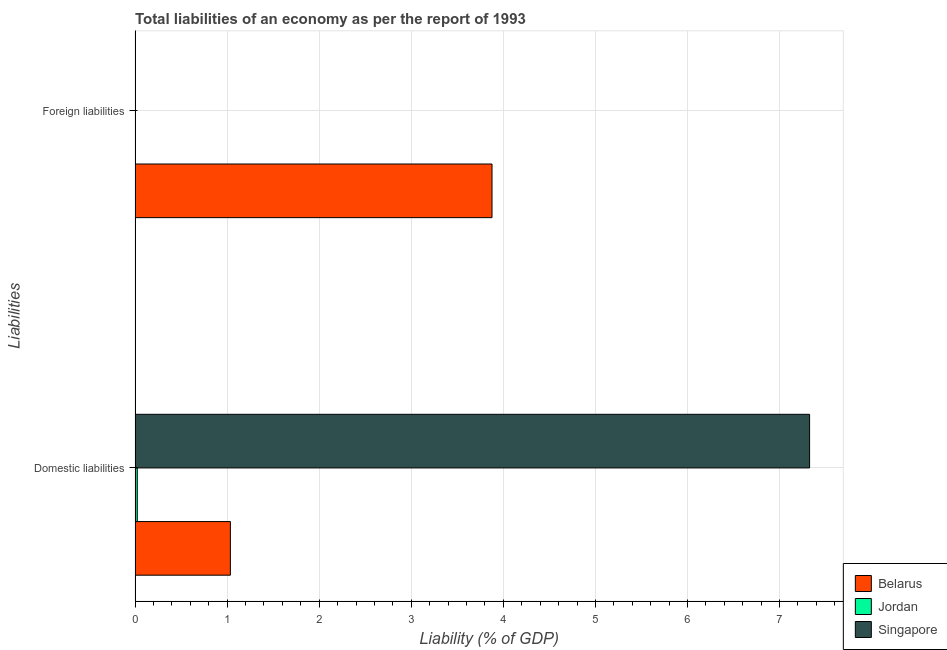How many different coloured bars are there?
Offer a terse response. 3. How many bars are there on the 1st tick from the bottom?
Your answer should be very brief. 3. What is the label of the 2nd group of bars from the top?
Your answer should be very brief. Domestic liabilities. What is the incurrence of foreign liabilities in Jordan?
Offer a terse response. 0. Across all countries, what is the maximum incurrence of domestic liabilities?
Provide a succinct answer. 7.33. Across all countries, what is the minimum incurrence of domestic liabilities?
Your answer should be compact. 0.02. In which country was the incurrence of foreign liabilities maximum?
Your answer should be very brief. Belarus. What is the total incurrence of domestic liabilities in the graph?
Your answer should be very brief. 8.39. What is the difference between the incurrence of domestic liabilities in Singapore and that in Jordan?
Your answer should be compact. 7.3. What is the difference between the incurrence of domestic liabilities in Belarus and the incurrence of foreign liabilities in Jordan?
Give a very brief answer. 1.04. What is the average incurrence of foreign liabilities per country?
Provide a short and direct response. 1.29. What is the difference between the incurrence of foreign liabilities and incurrence of domestic liabilities in Belarus?
Provide a short and direct response. 2.84. What is the ratio of the incurrence of domestic liabilities in Belarus to that in Jordan?
Provide a succinct answer. 43.24. How many countries are there in the graph?
Offer a terse response. 3. Are the values on the major ticks of X-axis written in scientific E-notation?
Your response must be concise. No. Does the graph contain any zero values?
Keep it short and to the point. Yes. Does the graph contain grids?
Keep it short and to the point. Yes. What is the title of the graph?
Offer a very short reply. Total liabilities of an economy as per the report of 1993. What is the label or title of the X-axis?
Keep it short and to the point. Liability (% of GDP). What is the label or title of the Y-axis?
Make the answer very short. Liabilities. What is the Liability (% of GDP) in Belarus in Domestic liabilities?
Keep it short and to the point. 1.04. What is the Liability (% of GDP) of Jordan in Domestic liabilities?
Offer a very short reply. 0.02. What is the Liability (% of GDP) in Singapore in Domestic liabilities?
Make the answer very short. 7.33. What is the Liability (% of GDP) in Belarus in Foreign liabilities?
Your answer should be compact. 3.88. Across all Liabilities, what is the maximum Liability (% of GDP) of Belarus?
Give a very brief answer. 3.88. Across all Liabilities, what is the maximum Liability (% of GDP) of Jordan?
Ensure brevity in your answer.  0.02. Across all Liabilities, what is the maximum Liability (% of GDP) of Singapore?
Offer a very short reply. 7.33. Across all Liabilities, what is the minimum Liability (% of GDP) of Belarus?
Give a very brief answer. 1.04. Across all Liabilities, what is the minimum Liability (% of GDP) of Singapore?
Provide a succinct answer. 0. What is the total Liability (% of GDP) of Belarus in the graph?
Offer a very short reply. 4.91. What is the total Liability (% of GDP) in Jordan in the graph?
Ensure brevity in your answer.  0.02. What is the total Liability (% of GDP) in Singapore in the graph?
Make the answer very short. 7.33. What is the difference between the Liability (% of GDP) in Belarus in Domestic liabilities and that in Foreign liabilities?
Provide a succinct answer. -2.84. What is the average Liability (% of GDP) in Belarus per Liabilities?
Your response must be concise. 2.46. What is the average Liability (% of GDP) of Jordan per Liabilities?
Offer a terse response. 0.01. What is the average Liability (% of GDP) of Singapore per Liabilities?
Offer a very short reply. 3.66. What is the difference between the Liability (% of GDP) of Belarus and Liability (% of GDP) of Jordan in Domestic liabilities?
Provide a short and direct response. 1.01. What is the difference between the Liability (% of GDP) in Belarus and Liability (% of GDP) in Singapore in Domestic liabilities?
Provide a short and direct response. -6.29. What is the difference between the Liability (% of GDP) of Jordan and Liability (% of GDP) of Singapore in Domestic liabilities?
Your answer should be very brief. -7.3. What is the ratio of the Liability (% of GDP) in Belarus in Domestic liabilities to that in Foreign liabilities?
Give a very brief answer. 0.27. What is the difference between the highest and the second highest Liability (% of GDP) of Belarus?
Keep it short and to the point. 2.84. What is the difference between the highest and the lowest Liability (% of GDP) in Belarus?
Provide a short and direct response. 2.84. What is the difference between the highest and the lowest Liability (% of GDP) in Jordan?
Offer a terse response. 0.02. What is the difference between the highest and the lowest Liability (% of GDP) of Singapore?
Offer a very short reply. 7.33. 